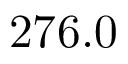<formula> <loc_0><loc_0><loc_500><loc_500>2 7 6 . 0</formula> 